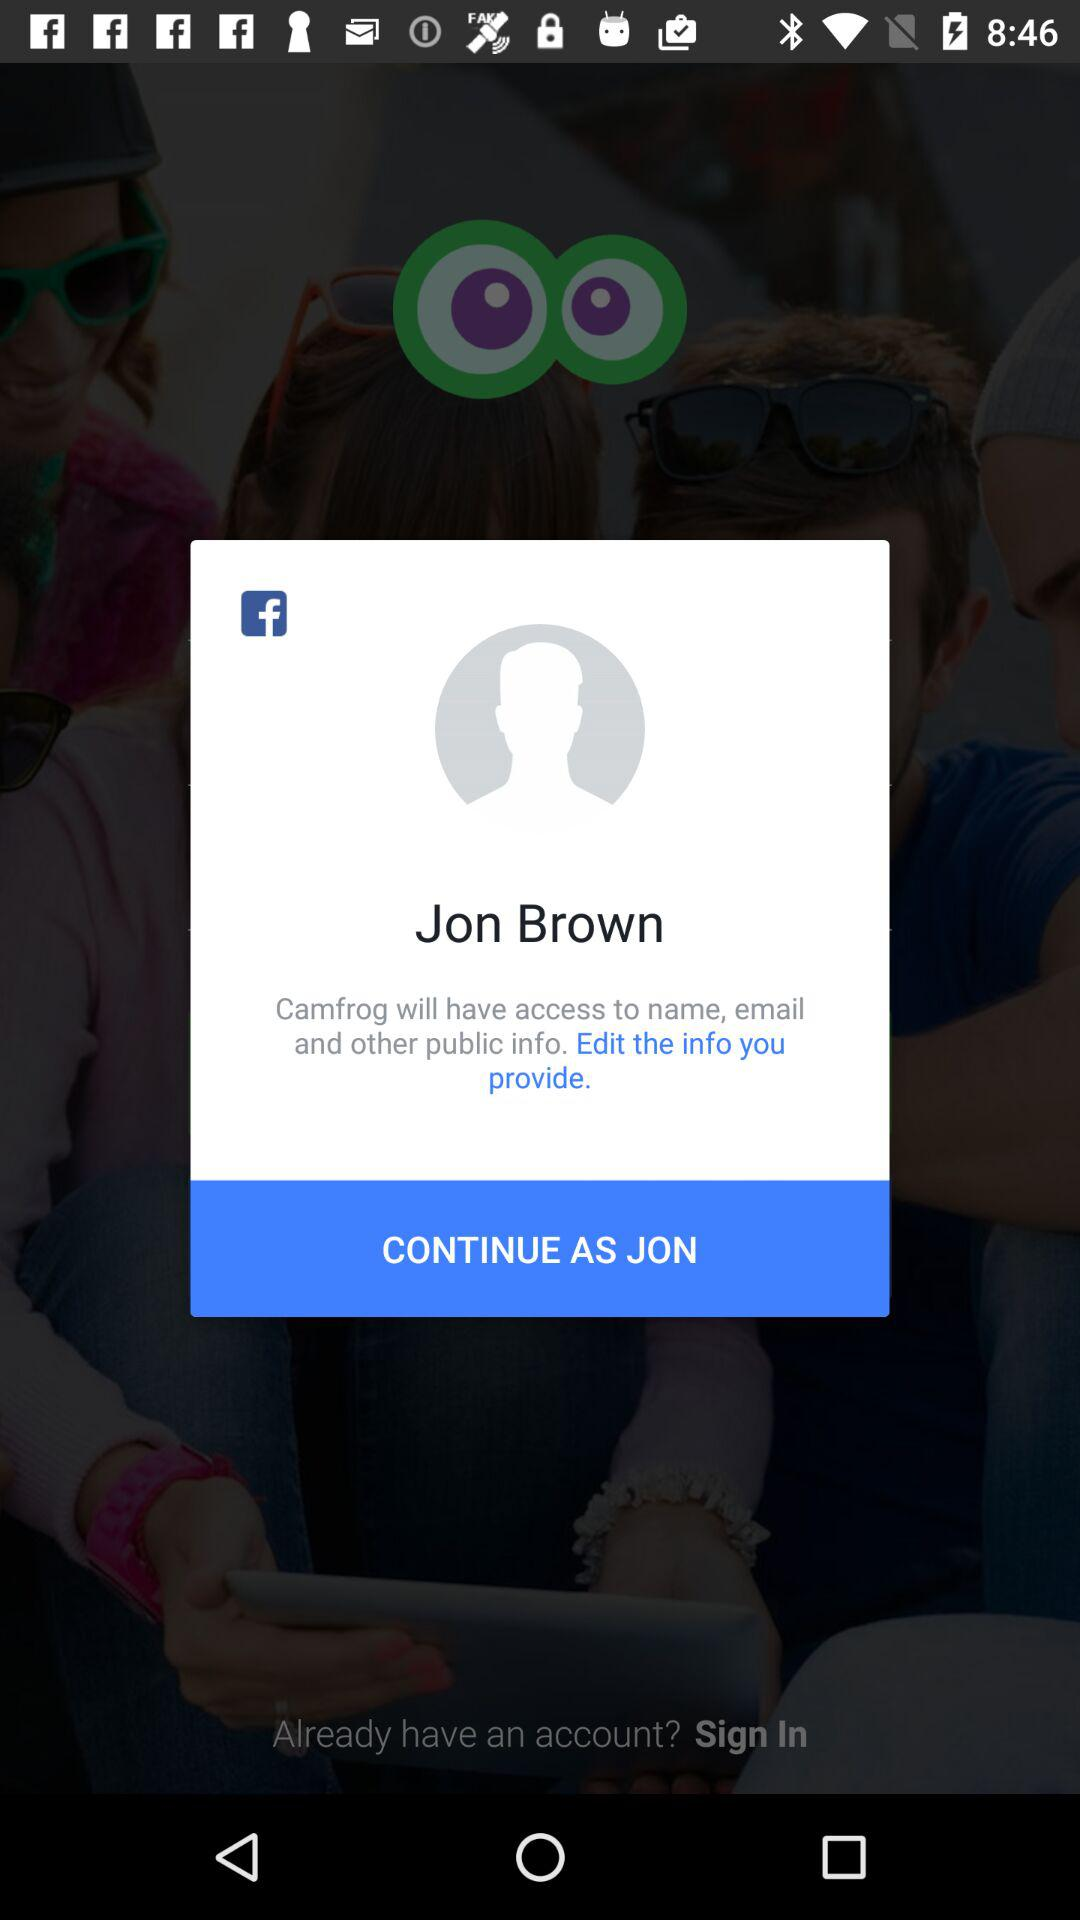What application is asking for permission? The application asking for permission is "Camfrog". 